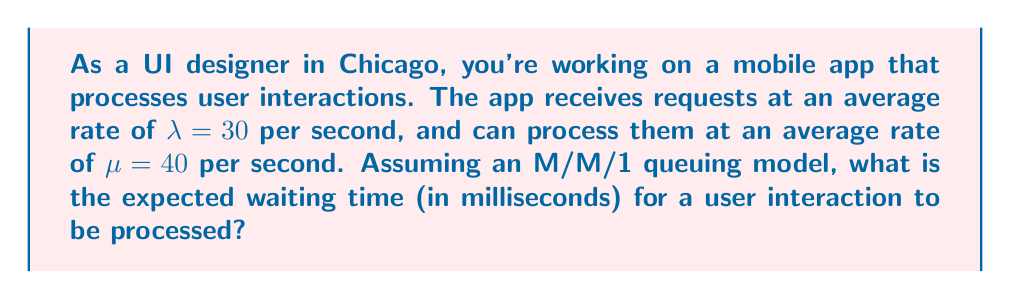What is the answer to this math problem? To solve this problem, we'll use the M/M/1 queuing model, which is appropriate for modeling user interface responsiveness. Let's follow these steps:

1. Calculate the utilization factor $\rho$:
   $\rho = \frac{\lambda}{\mu} = \frac{30}{40} = 0.75$

2. Calculate the expected number of requests in the system $L$:
   $L = \frac{\rho}{1-\rho} = \frac{0.75}{1-0.75} = 3$

3. Calculate the expected time spent in the system $W$ using Little's Law:
   $W = \frac{L}{\lambda} = \frac{3}{30} = 0.1$ seconds

4. Calculate the expected service time $\frac{1}{\mu}$:
   $\frac{1}{\mu} = \frac{1}{40} = 0.025$ seconds

5. Calculate the expected waiting time $W_q$:
   $W_q = W - \frac{1}{\mu} = 0.1 - 0.025 = 0.075$ seconds

6. Convert the waiting time to milliseconds:
   $W_q(\text{ms}) = 0.075 \times 1000 = 75$ milliseconds

Therefore, the expected waiting time for a user interaction to be processed is 75 milliseconds.
Answer: 75 ms 